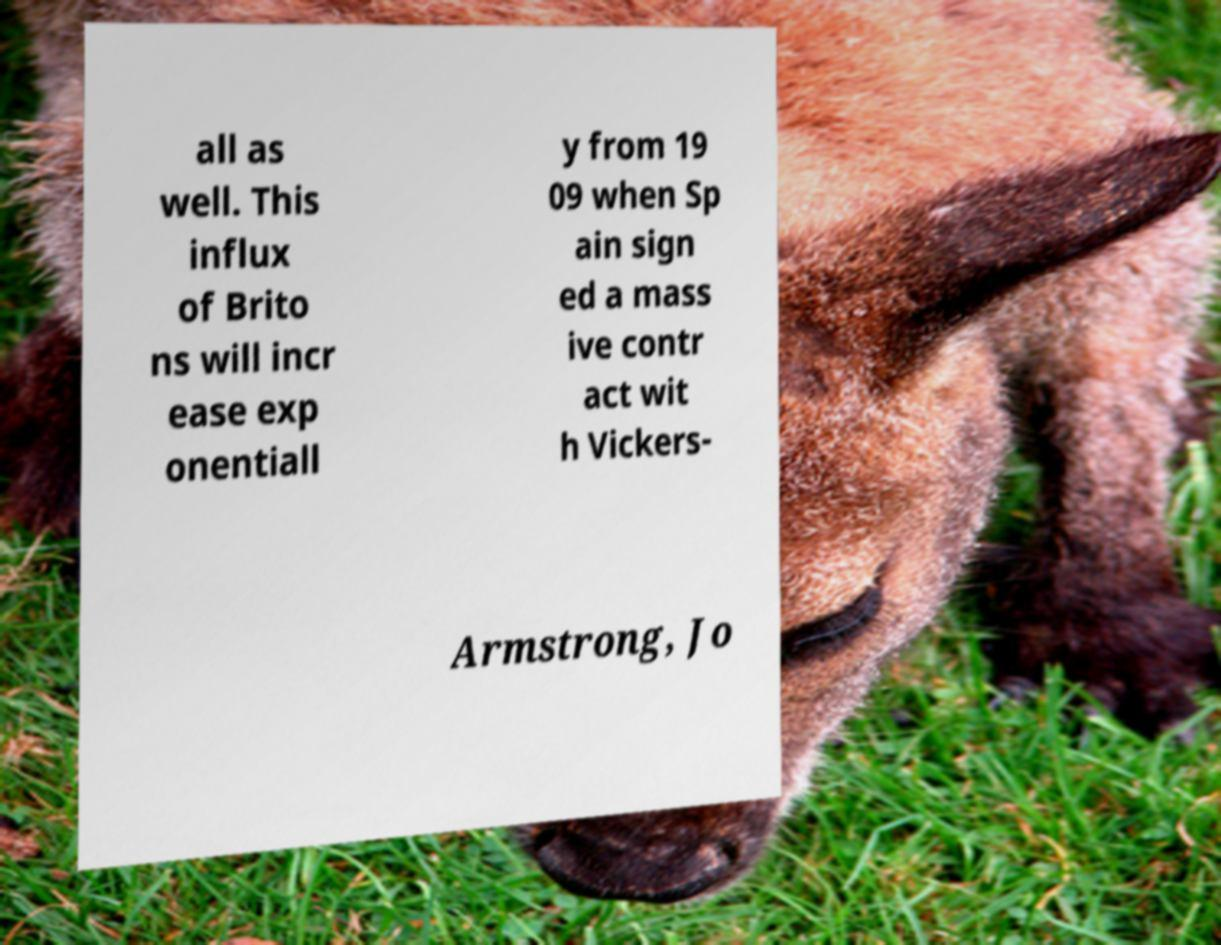Can you accurately transcribe the text from the provided image for me? all as well. This influx of Brito ns will incr ease exp onentiall y from 19 09 when Sp ain sign ed a mass ive contr act wit h Vickers- Armstrong, Jo 